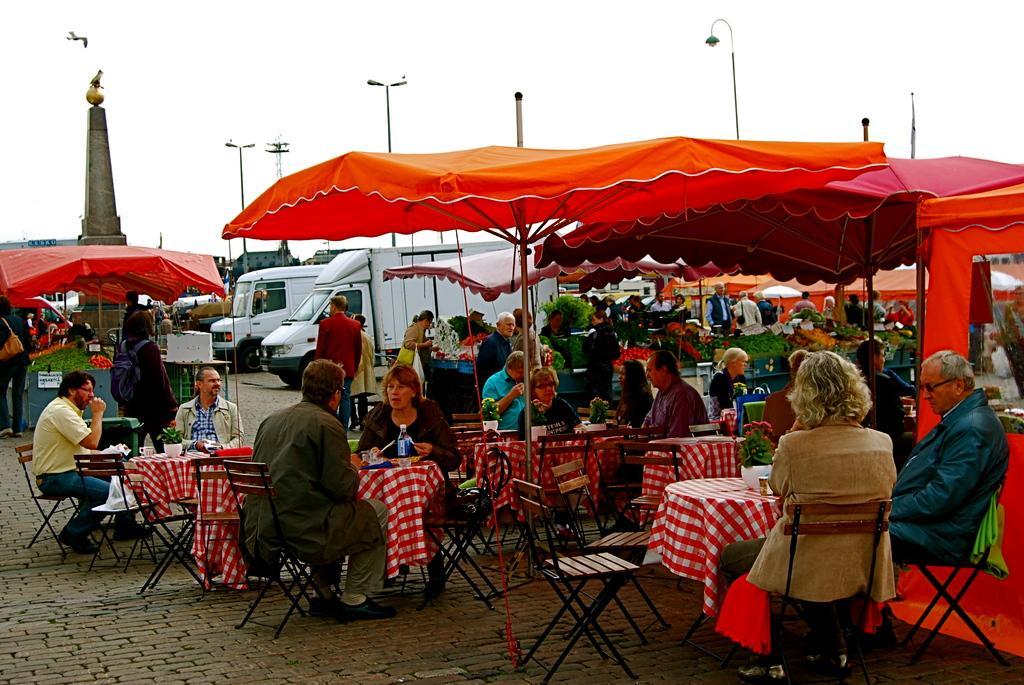Please provide a concise description of this image. In this image, there are a few people, chairs, poles, tents, vehicles and umbrellas. We can see the ground. We can also see some tables covered with a cloth and some objects are placed on it. We can also see a tomb and some food items. We can also see a board and the sky. We can also see a bird. 